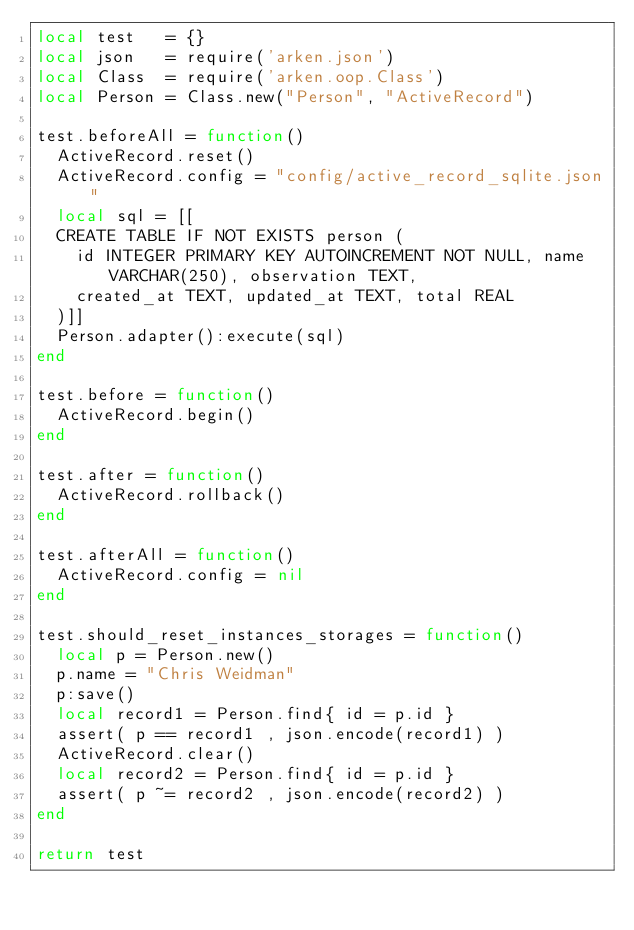Convert code to text. <code><loc_0><loc_0><loc_500><loc_500><_Lua_>local test   = {}
local json   = require('arken.json')
local Class  = require('arken.oop.Class')
local Person = Class.new("Person", "ActiveRecord")

test.beforeAll = function()
  ActiveRecord.reset()
  ActiveRecord.config = "config/active_record_sqlite.json"
  local sql = [[
  CREATE TABLE IF NOT EXISTS person (
    id INTEGER PRIMARY KEY AUTOINCREMENT NOT NULL, name VARCHAR(250), observation TEXT,
    created_at TEXT, updated_at TEXT, total REAL
  )]]
  Person.adapter():execute(sql)
end

test.before = function()
  ActiveRecord.begin()
end

test.after = function()
  ActiveRecord.rollback()
end

test.afterAll = function()
  ActiveRecord.config = nil
end

test.should_reset_instances_storages = function()
  local p = Person.new()
  p.name = "Chris Weidman"
  p:save()
  local record1 = Person.find{ id = p.id }
  assert( p == record1 , json.encode(record1) )
  ActiveRecord.clear()
  local record2 = Person.find{ id = p.id }
  assert( p ~= record2 , json.encode(record2) )
end

return test
</code> 